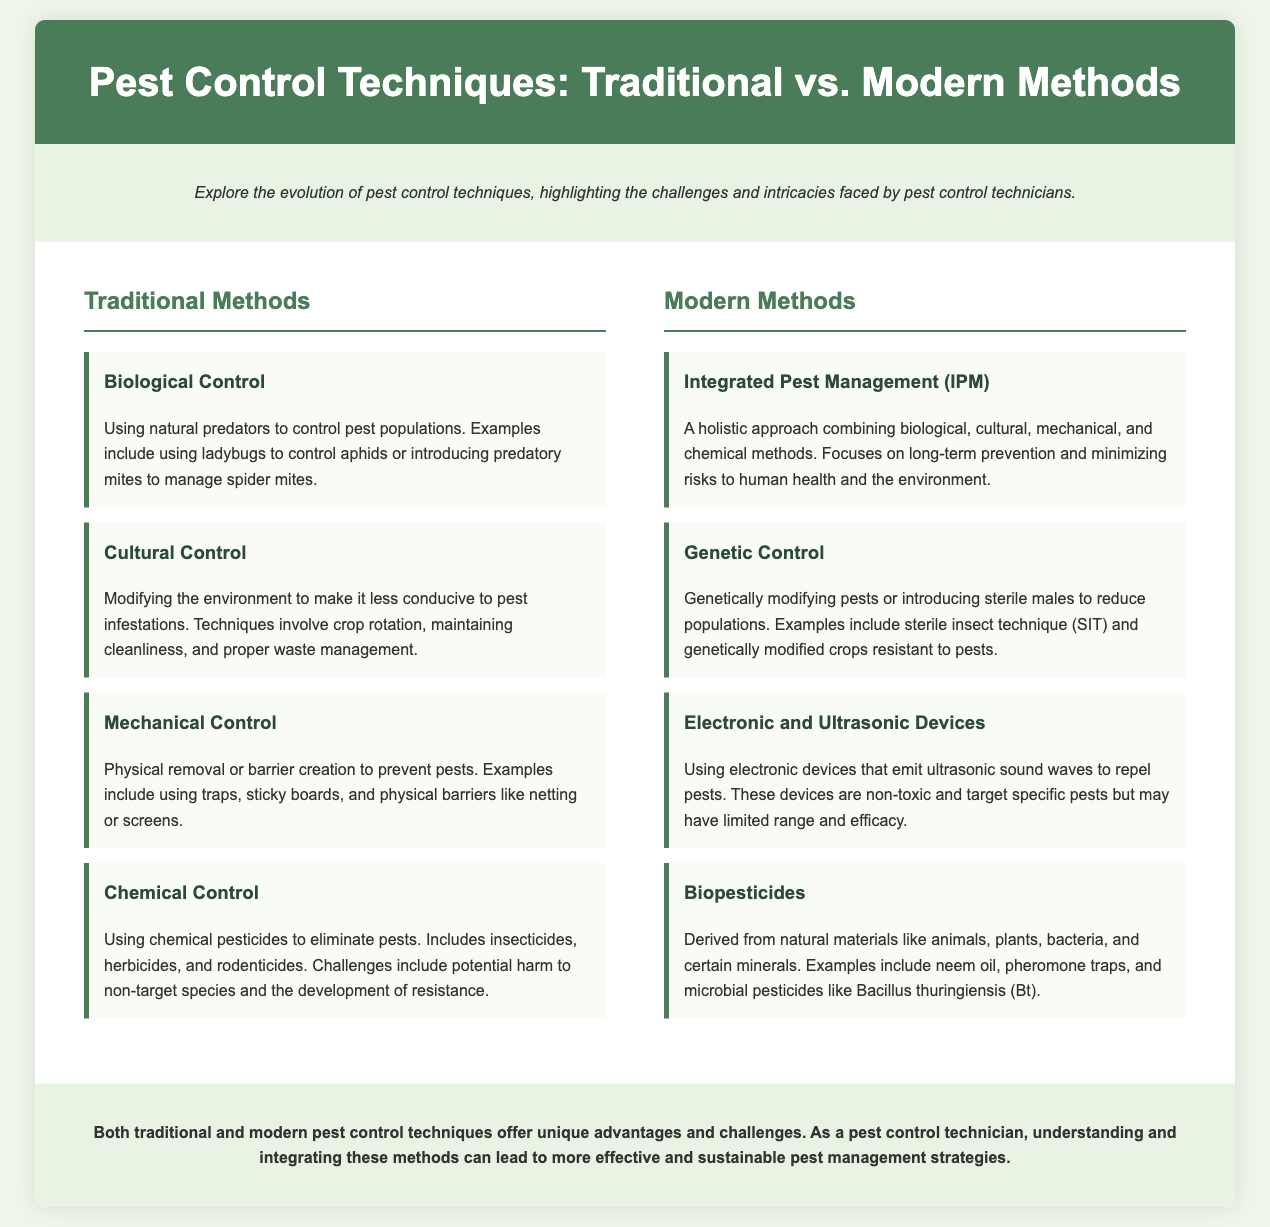what is a traditional method of pest control that uses natural predators? The document mentions "Biological Control" as a traditional method that uses natural predators to manage pest populations.
Answer: Biological Control what is a modern method that combines different pest control techniques? The document describes "Integrated Pest Management (IPM)" as a holistic approach that combines various methods for pest control.
Answer: Integrated Pest Management (IPM) which traditional method involves physical removal or barriers? The section on traditional methods indicates "Mechanical Control" as the method that involves physical removal or barrier creation.
Answer: Mechanical Control what is a challenge associated with chemical control methods? The document highlights that a challenge of "Chemical Control" includes the potential harm to non-target species and the development of resistance.
Answer: Harm to non-target species and resistance name a type of biopesticide mentioned in the document. The document provides examples of biopesticides, including "neem oil" and "Bacillus thuringiensis (Bt)."
Answer: neem oil what technique uses genetically modified crops? The document notes "Genetic Control" as a modern method that includes genetically modified crops resistant to pests.
Answer: Genetic Control what environmental modification technique is discussed in traditional methods? "Cultural Control" is mentioned as a method that modifies the environment to make it less suitable for pest infestations.
Answer: Cultural Control which modern pest control method is categorized by the use of electronic devices? The document refers to "Electronic and Ultrasonic Devices" as a modern pest control technique that utilizes electronic devices to repel pests.
Answer: Electronic and Ultrasonic Devices which modern method involves using sterile males to reduce pest populations? The technique mentioned in the document is "Genetic Control," which includes introducing sterile males to manage pest populations.
Answer: Genetic Control 